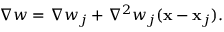<formula> <loc_0><loc_0><loc_500><loc_500>\begin{array} { r } { \nabla w = \nabla w _ { j } + { \nabla } ^ { 2 } w _ { j } ( { x } - { x } _ { j } ) . } \end{array}</formula> 